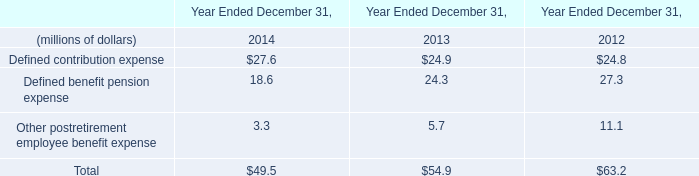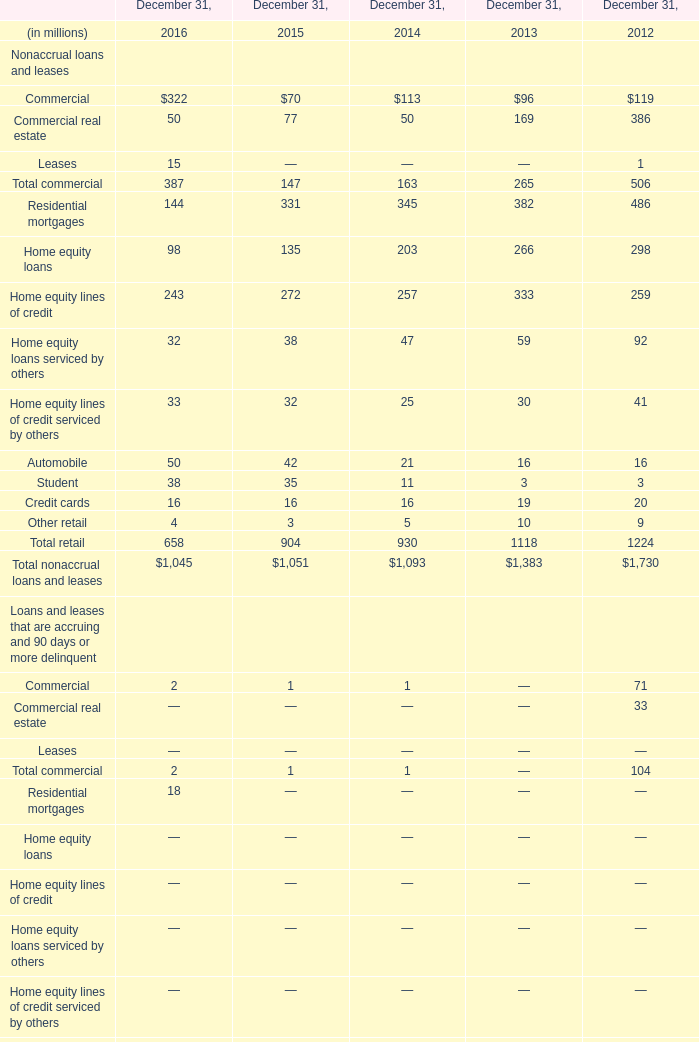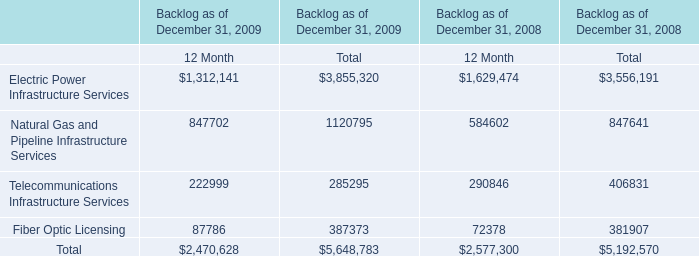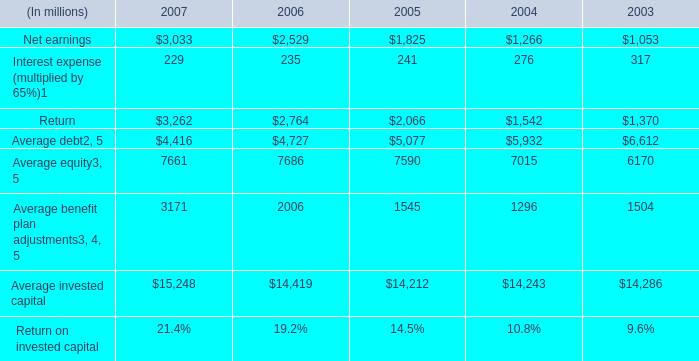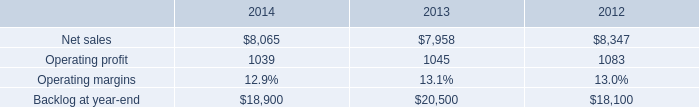What is the total amount of Operating profit of 2012, and Net earnings of 2007 ? 
Computations: (1083.0 + 3033.0)
Answer: 4116.0. 